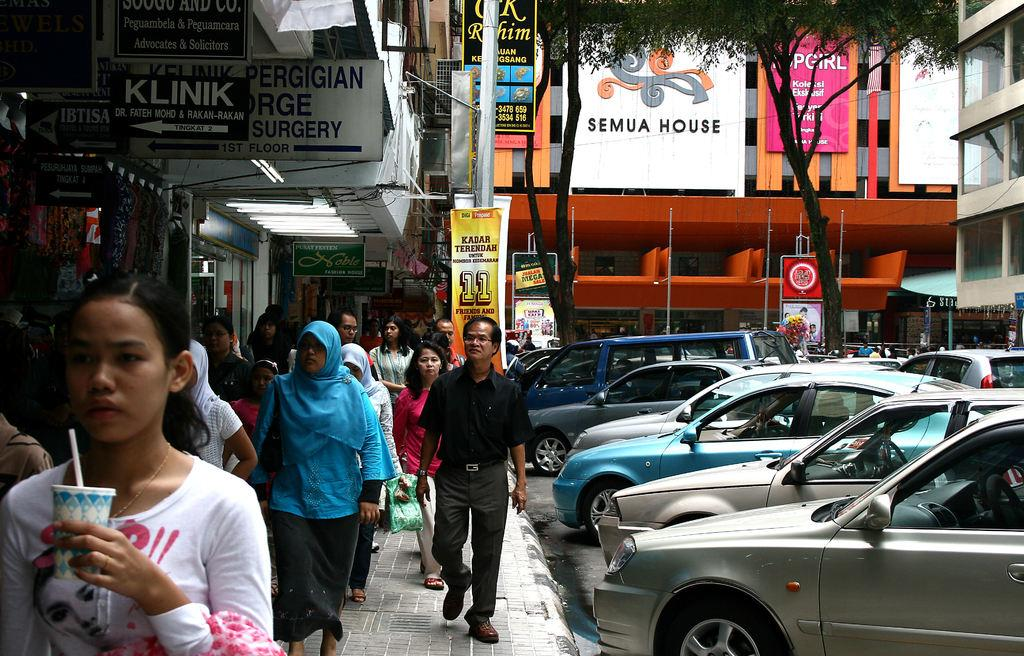<image>
Create a compact narrative representing the image presented. A sign for the Semua House hangs on a bright orange building. 